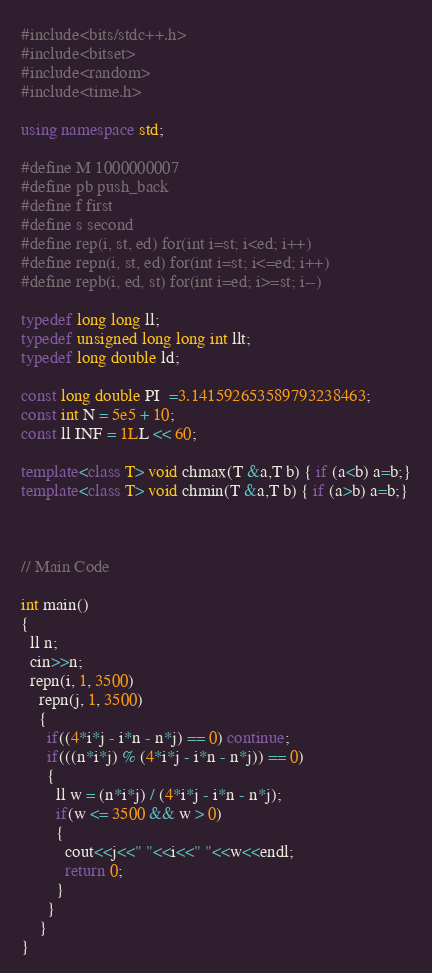<code> <loc_0><loc_0><loc_500><loc_500><_C++_>#include<bits/stdc++.h>
#include<bitset>
#include<random>
#include<time.h>

using namespace std;

#define M 1000000007
#define pb push_back
#define f first
#define s second
#define rep(i, st, ed) for(int i=st; i<ed; i++)
#define repn(i, st, ed) for(int i=st; i<=ed; i++)
#define repb(i, ed, st) for(int i=ed; i>=st; i--)

typedef long long ll;
typedef unsigned long long int llt;
typedef long double ld;

const long double PI  =3.141592653589793238463;
const int N = 5e5 + 10;
const ll INF = 1LL << 60;

template<class T> void chmax(T &a,T b) { if (a<b) a=b;}
template<class T> void chmin(T &a,T b) { if (a>b) a=b;}



// Main Code

int main()
{
  ll n;
  cin>>n;
  repn(i, 1, 3500)
    repn(j, 1, 3500)
    {
      if((4*i*j - i*n - n*j) == 0) continue;
      if(((n*i*j) % (4*i*j - i*n - n*j)) == 0)
      {
        ll w = (n*i*j) / (4*i*j - i*n - n*j);
        if(w <= 3500 && w > 0)
        {
          cout<<j<<" "<<i<<" "<<w<<endl;
          return 0;
        }
      }
    }
}
</code> 